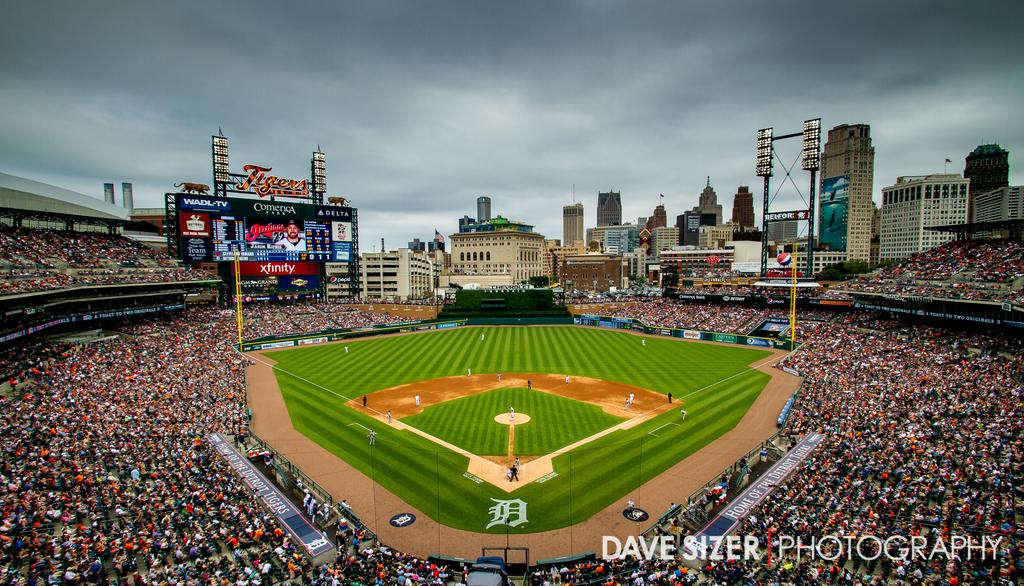<image>
Share a concise interpretation of the image provided. Dave Sizer took a photo of the crowd and field at a baseball game 